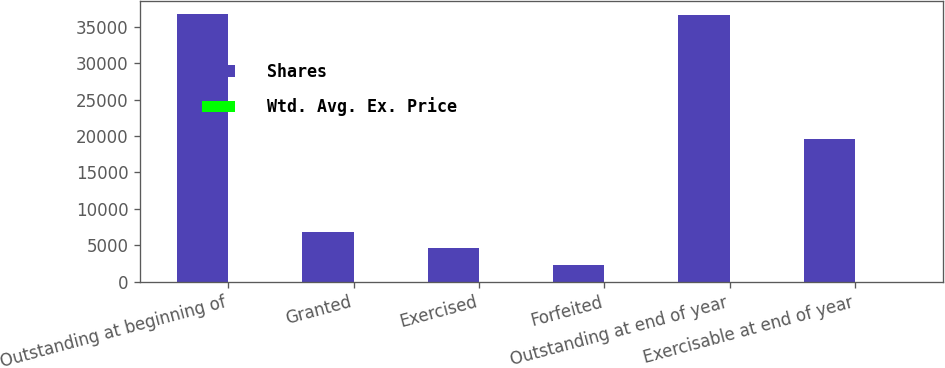Convert chart. <chart><loc_0><loc_0><loc_500><loc_500><stacked_bar_chart><ecel><fcel>Outstanding at beginning of<fcel>Granted<fcel>Exercised<fcel>Forfeited<fcel>Outstanding at end of year<fcel>Exercisable at end of year<nl><fcel>Shares<fcel>36710<fcel>6795<fcel>4585<fcel>2282<fcel>36638<fcel>19600<nl><fcel>Wtd. Avg. Ex. Price<fcel>6.35<fcel>7.22<fcel>4.87<fcel>8.07<fcel>6.59<fcel>5.26<nl></chart> 